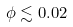Convert formula to latex. <formula><loc_0><loc_0><loc_500><loc_500>\phi \lesssim 0 . 0 2</formula> 